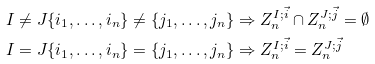Convert formula to latex. <formula><loc_0><loc_0><loc_500><loc_500>I \neq J \{ i _ { 1 } , \dots , i _ { n } \} \neq \{ j _ { 1 } , \dots , j _ { n } \} & \Rightarrow Z ^ { I ; \vec { i } } _ { n } \cap Z ^ { J ; \vec { j } } _ { n } = \emptyset \\ I = J \{ i _ { 1 } , \dots , i _ { n } \} = \{ j _ { 1 } , \dots , j _ { n } \} & \Rightarrow Z ^ { I ; \vec { i } } _ { n } = Z ^ { J ; \vec { j } } _ { n }</formula> 